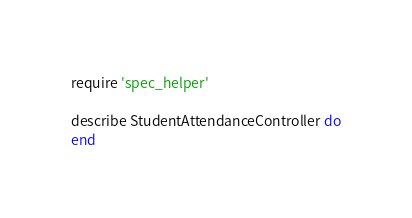<code> <loc_0><loc_0><loc_500><loc_500><_Ruby_>require 'spec_helper'

describe StudentAttendanceController do
end</code> 